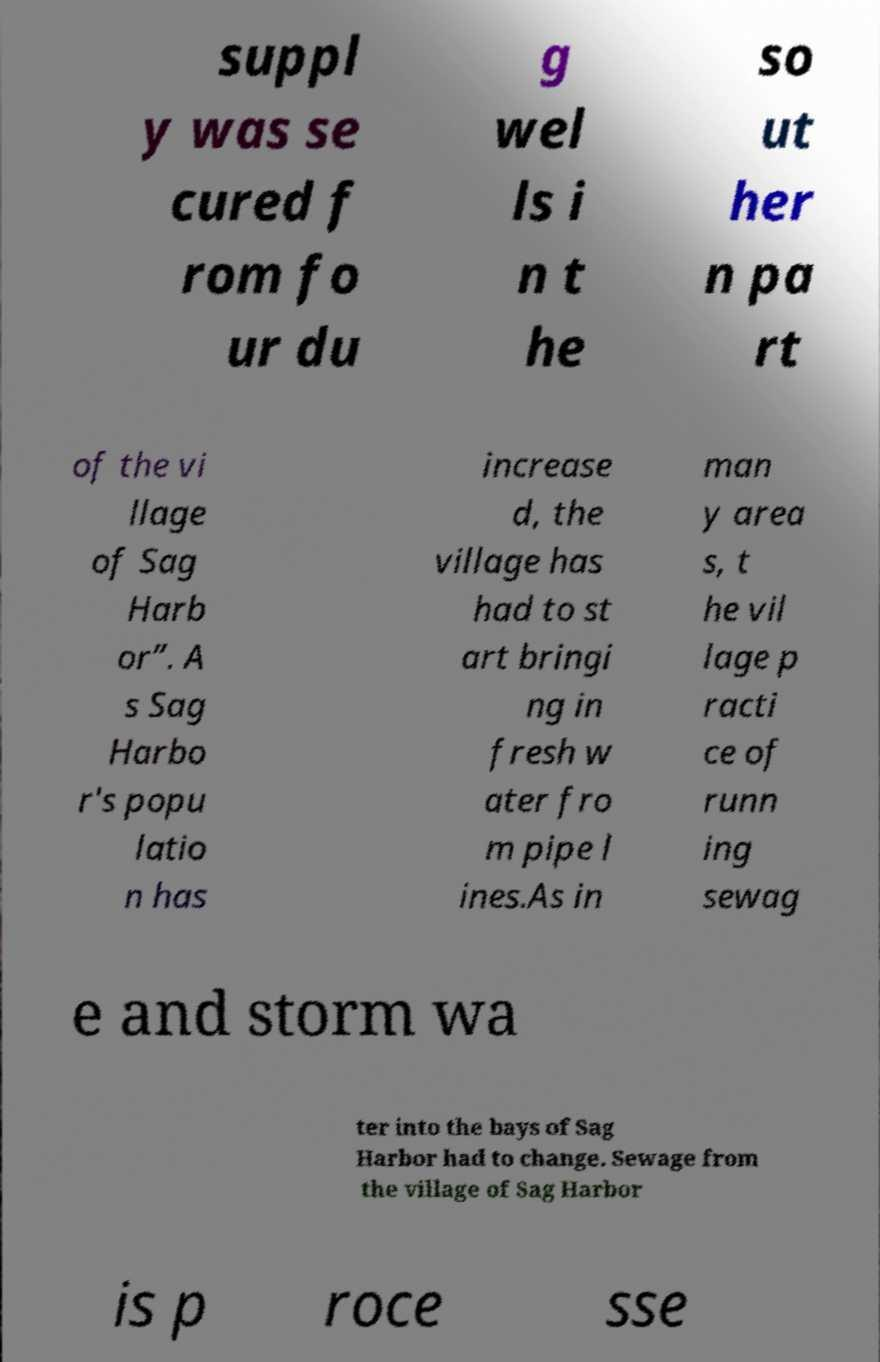For documentation purposes, I need the text within this image transcribed. Could you provide that? suppl y was se cured f rom fo ur du g wel ls i n t he so ut her n pa rt of the vi llage of Sag Harb or”. A s Sag Harbo r's popu latio n has increase d, the village has had to st art bringi ng in fresh w ater fro m pipe l ines.As in man y area s, t he vil lage p racti ce of runn ing sewag e and storm wa ter into the bays of Sag Harbor had to change. Sewage from the village of Sag Harbor is p roce sse 